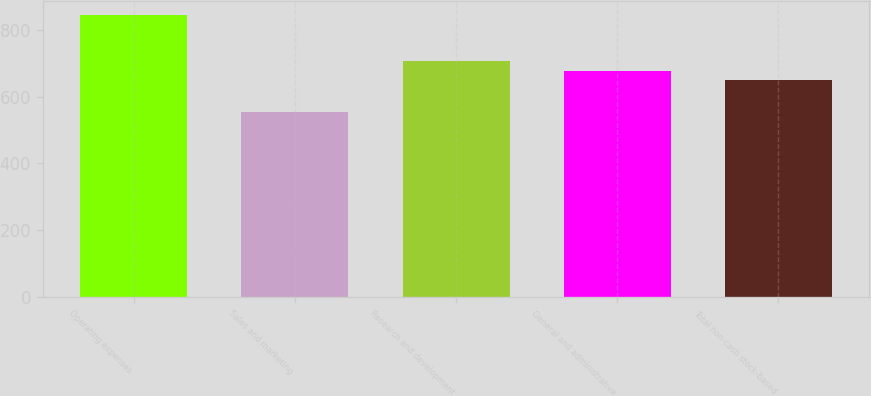Convert chart to OTSL. <chart><loc_0><loc_0><loc_500><loc_500><bar_chart><fcel>Operating expenses<fcel>Sales and marketing<fcel>Research and development<fcel>General and administrative<fcel>Total non-cash stock-based<nl><fcel>843<fcel>554<fcel>706.8<fcel>677.9<fcel>649<nl></chart> 